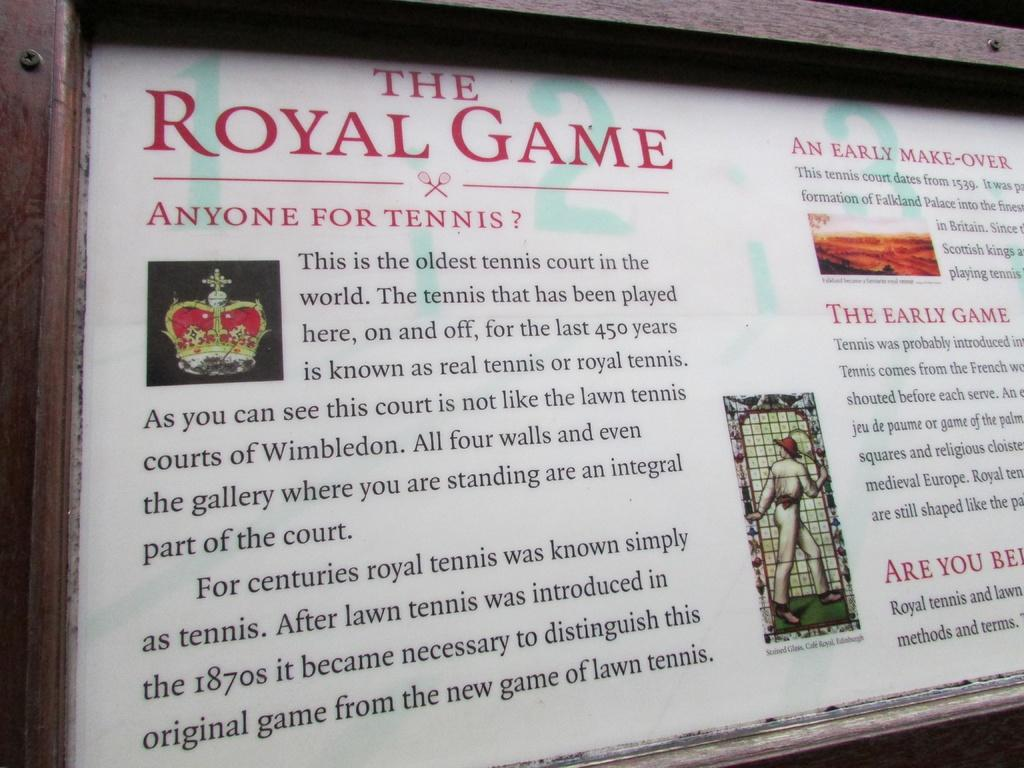Provide a one-sentence caption for the provided image. A sign displays the history of The Royal Game. 